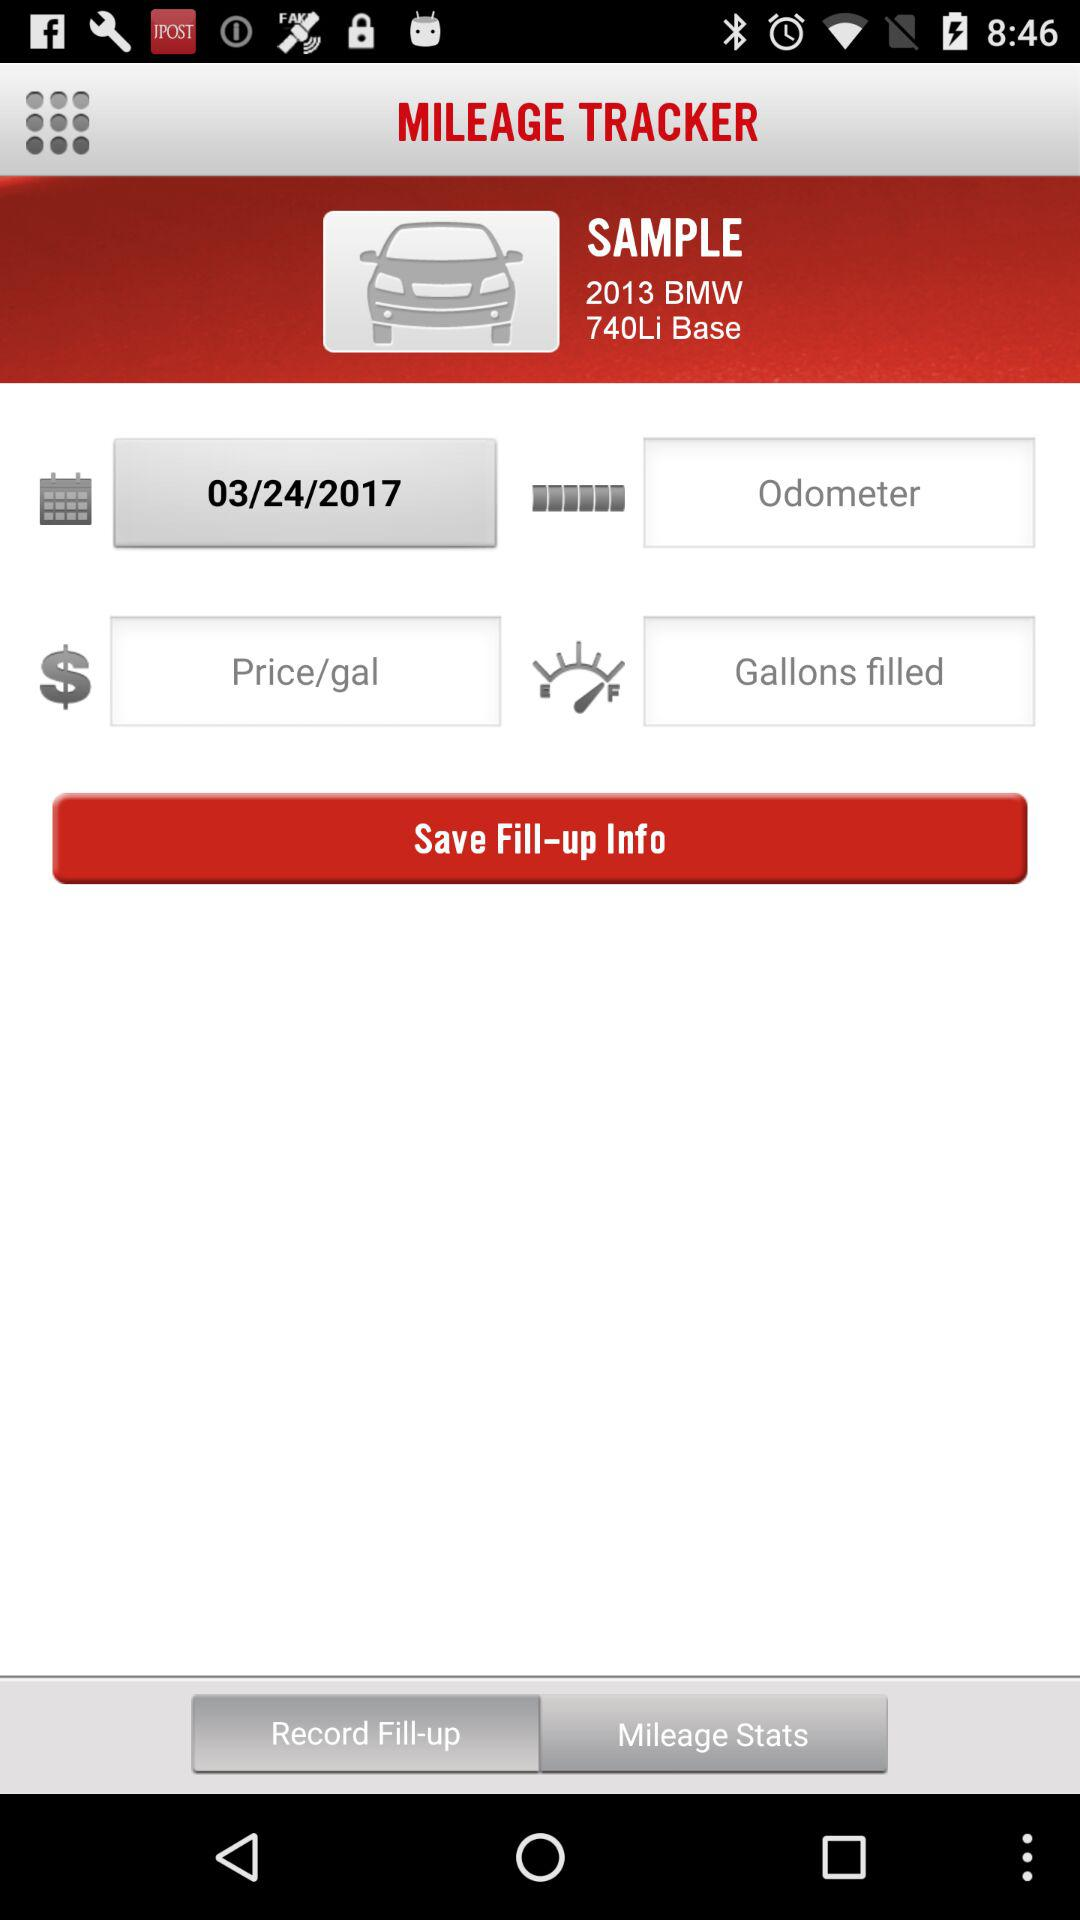What is the name of the car? The name of the car is "2013 BMW 740Li Base". 